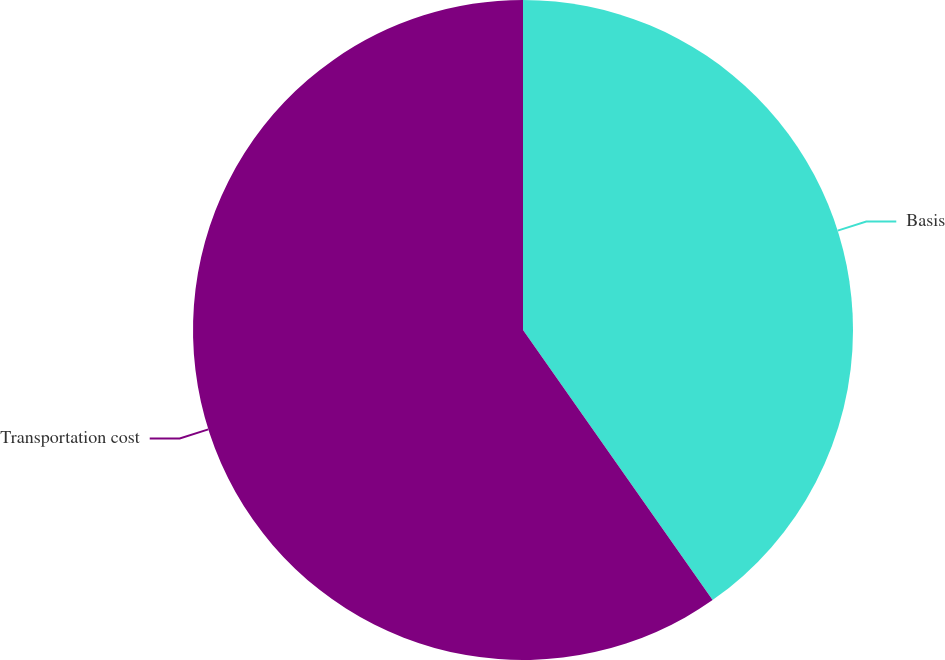Convert chart to OTSL. <chart><loc_0><loc_0><loc_500><loc_500><pie_chart><fcel>Basis<fcel>Transportation cost<nl><fcel>40.26%<fcel>59.74%<nl></chart> 